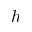<formula> <loc_0><loc_0><loc_500><loc_500>h</formula> 